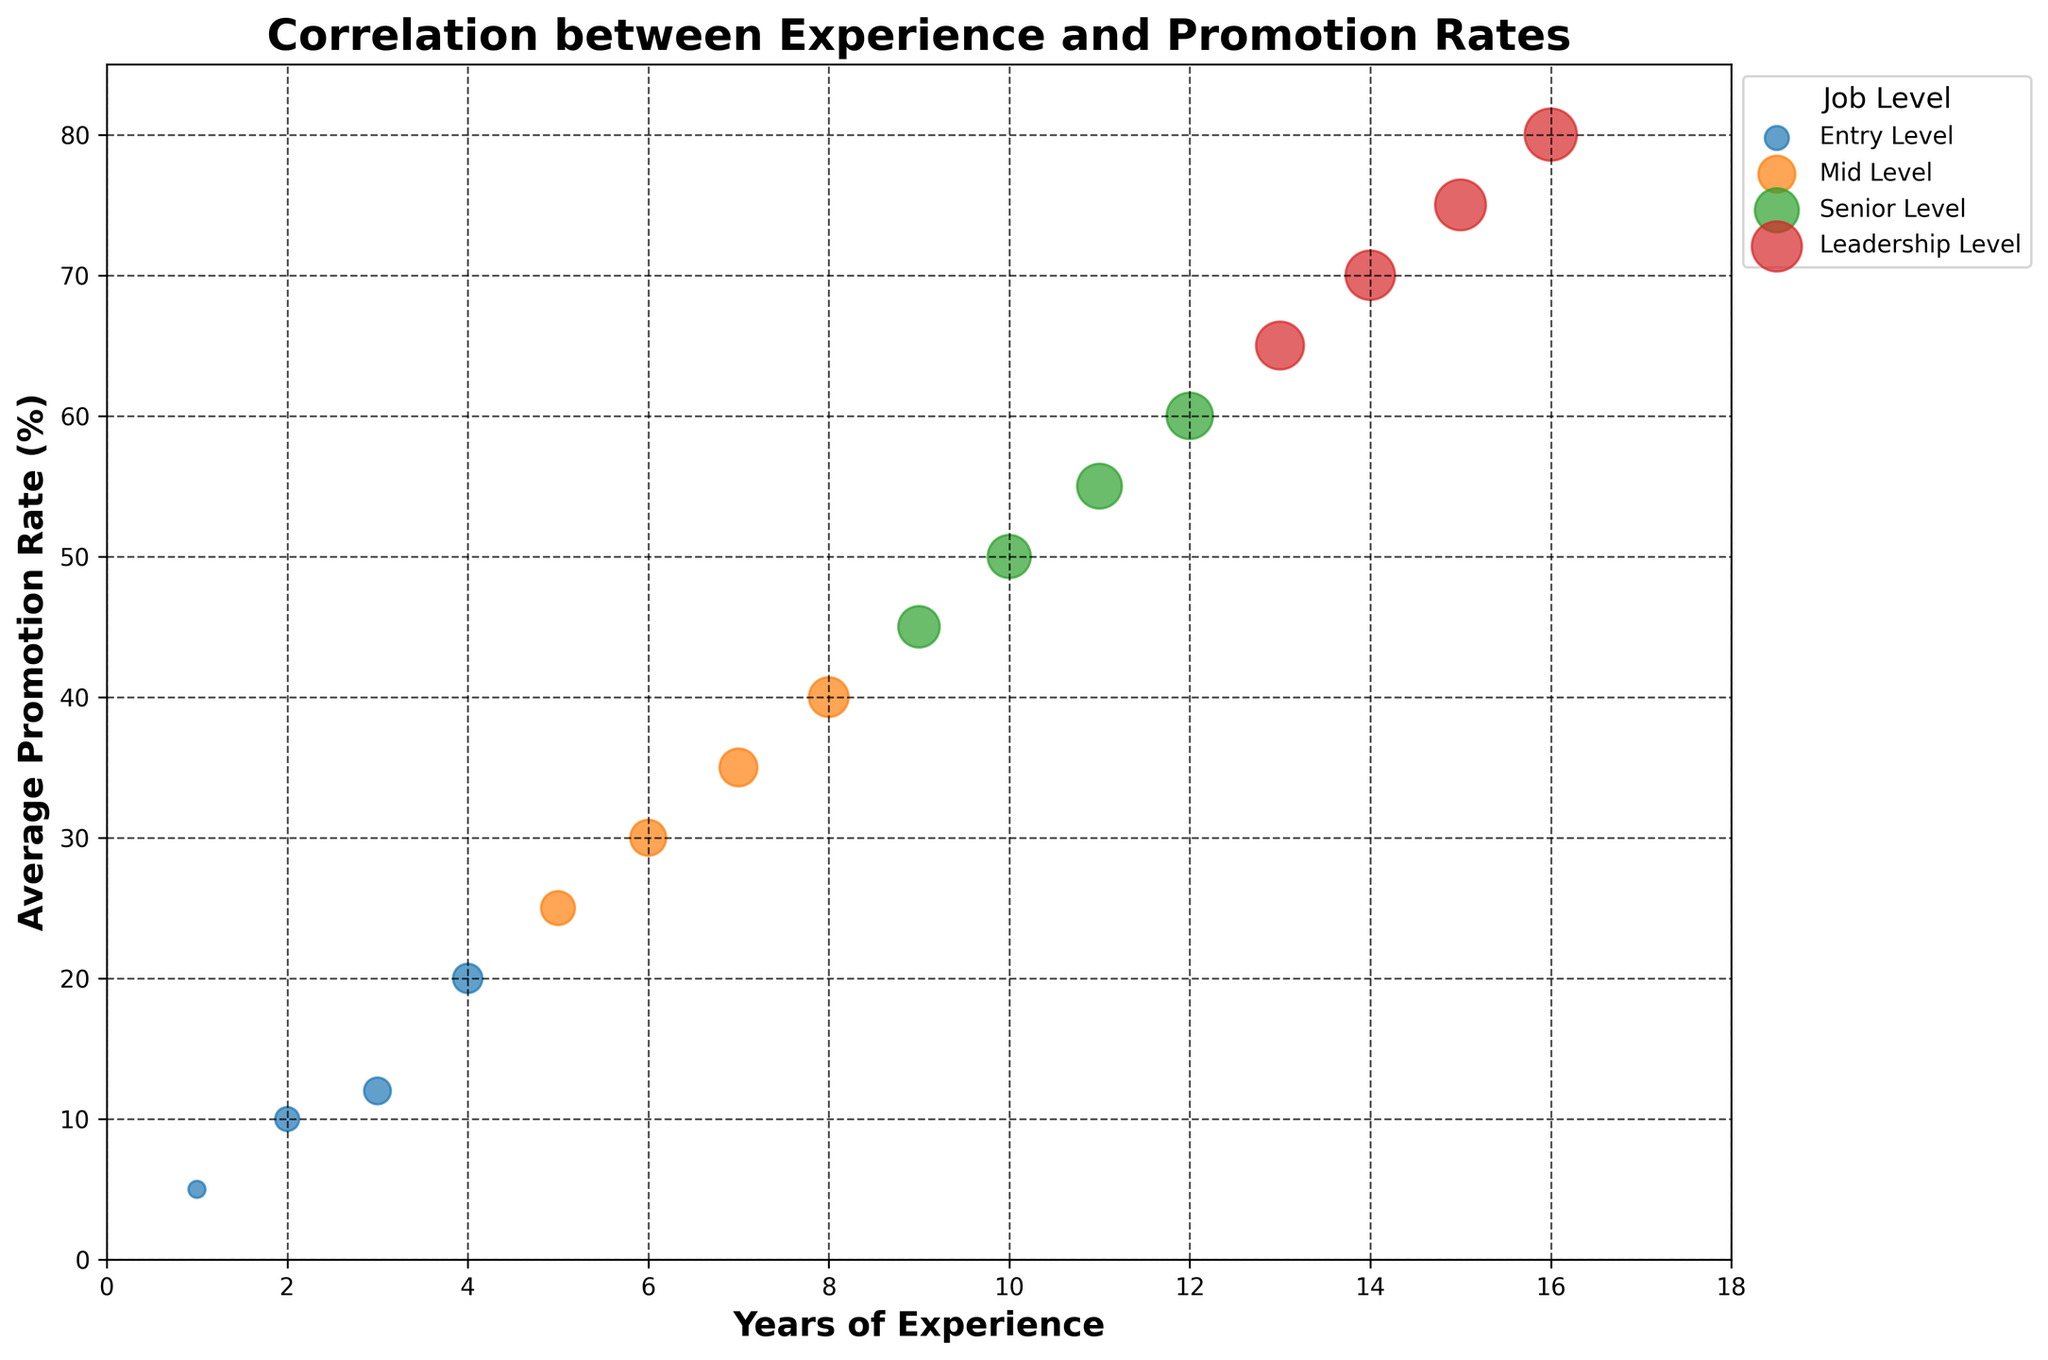What's the title of the plot? The title of the plot is located at the top of the figure.
Answer: Correlation between Experience and Promotion Rates How many job levels are represented in the plot? Each job level is distinguished by color and a legend on the right side of the plot shows the job levels with their corresponding colors.
Answer: 4 What is the average promotion rate for Entry Level with 4 years of experience? Locate the data point for Entry Level at 4 years of experience on the x-axis and check its corresponding y-axis value.
Answer: 20% Which job level shows the highest average promotion rate? The highest point on the y-axis falls within the Leadership Level, as indicated by the corresponding color.
Answer: Leadership Level At which years of experience do Mid Level and Senior Level intersect in their promotion rates? Find the data points where both levels have the same average promotion rate, which occurs when both lines cross over the same y-value.
Answer: 9 years of experience and 45% Which job level has the largest bubble size, and at what years of experience? Look for the largest bubble in size which falls within the Leadership Level, at 16 years of experience.
Answer: Leadership Level and 16 years How does the average promotion rate change from 1 year to 4 years of experience at Entry Level? Check the y-axis values for those specific years and calculate the change: from 5% to 20%.
Answer: Increases by 15% Compare the average promotion rate for Mid Level with 5 years of experience to that with 8 years of experience. Locate both data points and their y-axis values, 25% for 5 years and 40% for 8 years.
Answer: 15% higher at 8 years than at 5 years What's the trend in promotion rates for Senior Level from 9 to 12 years of experience? Follow the data points along the x-axis from 9 to 12 years, noting that the points form an upward trend as promotion rates increase.
Answer: Increasing trend What's the promotion rate difference between Leadership Level at 13 years and Senior Level at 10 years of experience? Find the corresponding y-axis values for Leadership Level at 13 years (65%) and Senior Level at 10 years (50%), then compute the difference (65% - 50%).
Answer: 15% 